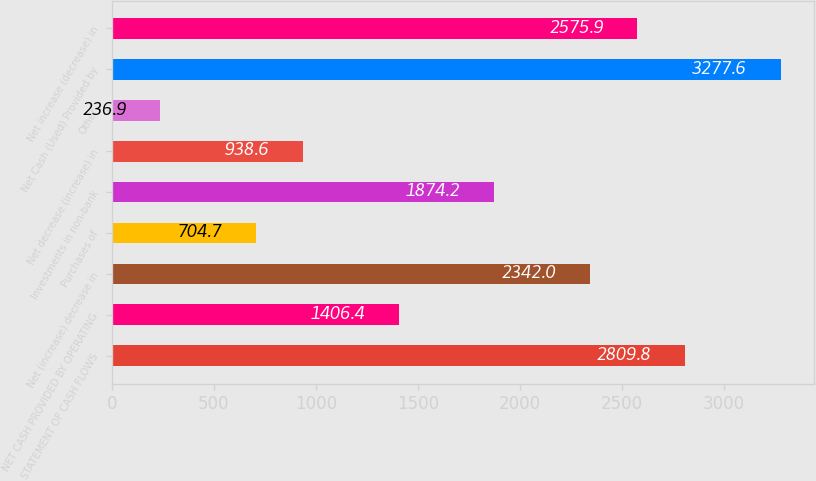<chart> <loc_0><loc_0><loc_500><loc_500><bar_chart><fcel>STATEMENT OF CASH FLOWS<fcel>NET CASH PROVIDED BY OPERATING<fcel>Net (increase) decrease in<fcel>Purchases of<fcel>Investments in non-bank<fcel>Net decrease (increase) in<fcel>Other<fcel>Net Cash (Used) Provided by<fcel>Net increase (decrease) in<nl><fcel>2809.8<fcel>1406.4<fcel>2342<fcel>704.7<fcel>1874.2<fcel>938.6<fcel>236.9<fcel>3277.6<fcel>2575.9<nl></chart> 